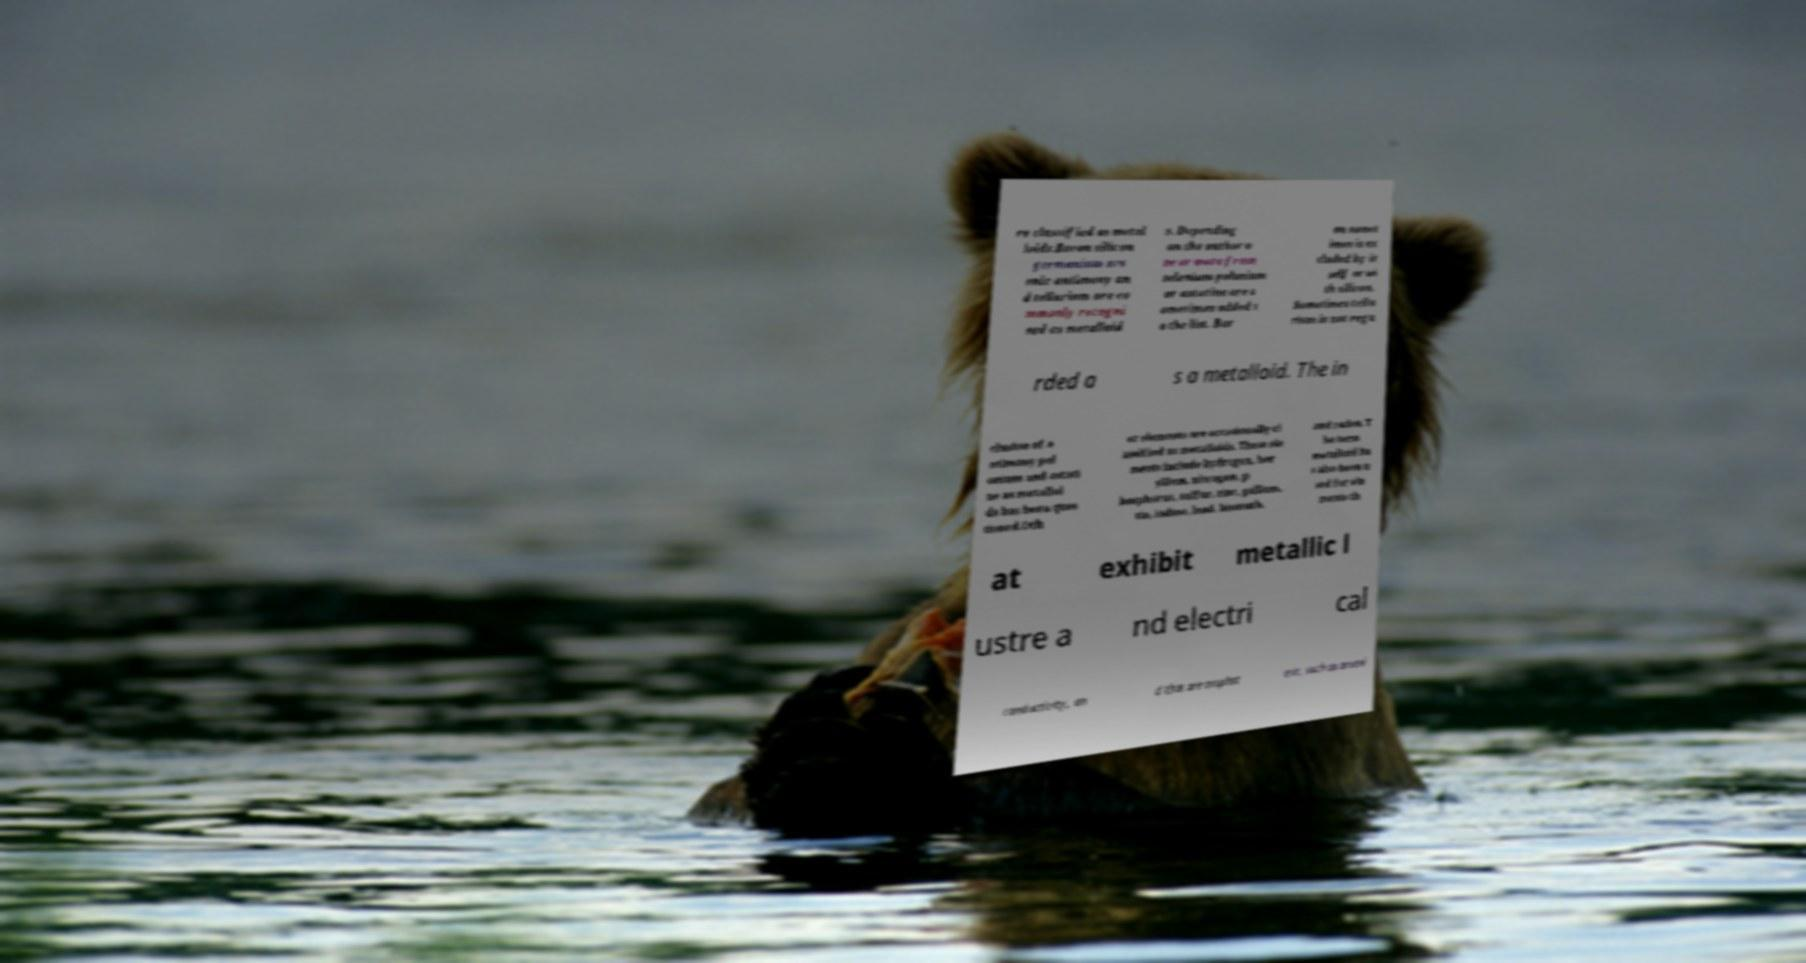I need the written content from this picture converted into text. Can you do that? re classified as metal loids.Boron silicon germanium ars enic antimony an d tellurium are co mmonly recogni sed as metalloid s. Depending on the author o ne or more from selenium polonium or astatine are s ometimes added t o the list. Bor on somet imes is ex cluded by it self or wi th silicon. Sometimes tellu rium is not rega rded a s a metalloid. The in clusion of a ntimony pol onium and astati ne as metalloi ds has been ques tioned.Oth er elements are occasionally cl assified as metalloids. These ele ments include hydrogen, ber yllium, nitrogen, p hosphorus, sulfur, zinc, gallium, tin, iodine, lead, bismuth, and radon. T he term metalloid ha s also been u sed for ele ments th at exhibit metallic l ustre a nd electri cal conductivity, an d that are amphot eric, such as arseni 